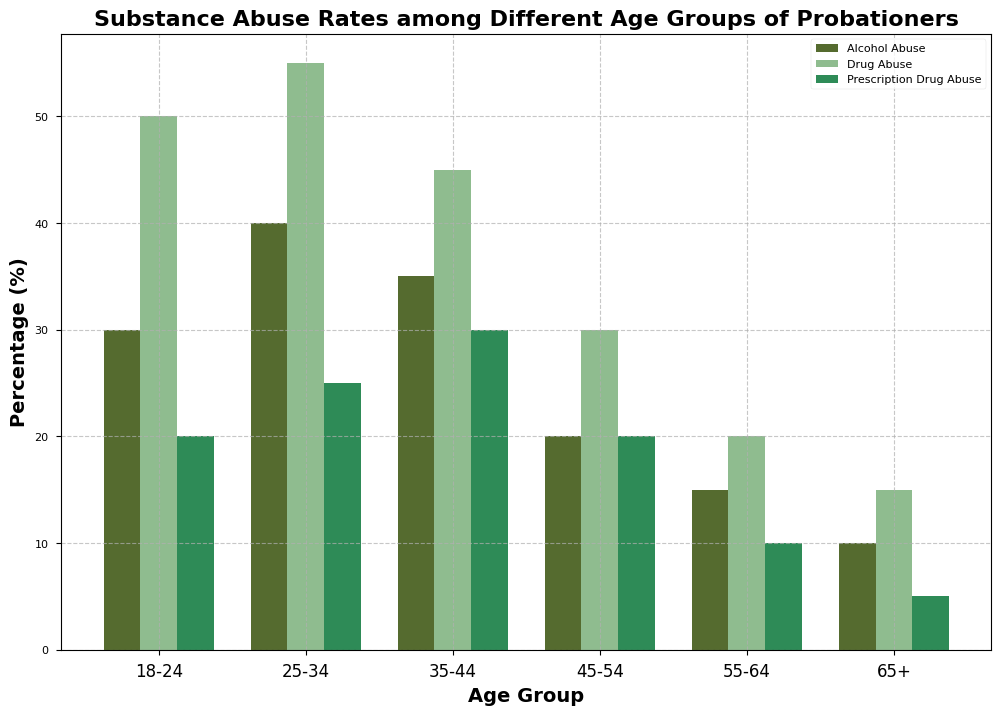Which age group has the highest rate of drug abuse? By visually comparing the heights of the drug abuse bars, the age group 25-34 has the highest bar.
Answer: 25-34 Which age group has the lowest rate of alcohol abuse? By visually examining the heights of the alcohol abuse bars, the 65+ age group has the shortest bar.
Answer: 65+ What is the difference in drug abuse rates between the age groups 25-34 and 45-54? The drug abuse rate for 25-34 age group is 55%, and for 45-54 age group, it is 30%. The difference is 55 - 30 = 25%.
Answer: 25% Which type of substance abuse has the highest average rate across all age groups? Calculate the average rate for alcohol, drug, and prescription drug abuse across all age groups. For alcohol: (30 + 40 + 35 + 20 + 15 + 10)/6 = 25%, for drug: (50 + 55 + 45 + 30 + 20 + 15)/6 = 35.83%, for prescription: (20 + 25 + 30 + 20 + 10 + 5)/6 = 18.33%. Drug abuse has the highest average rate.
Answer: Drug Abuse What is the combined total rate of all types of substance abuse for the age group 18-24? Sum the rates of alcohol (30%), drug (50%), and prescription drug (20%) abuse for 18-24 age group. 30 + 50 + 20 = 100%.
Answer: 100% What is the average rate of drug abuse across the age groups 35-44 and 55-64? Calculate the average for the drug abuse rates for the 35-44 (45%) and 55-64 (20%) age groups: (45 + 20) / 2 = 32.5%.
Answer: 32.5% Which age group has a higher difference in rates between alcohol abuse and prescription drug abuse, 18-24 or 45-54? The difference for 18-24 is 30 - 20 = 10%, and for 45-54 is 20 - 20 = 0%. Therefore, 18-24 has a higher difference.
Answer: 18-24 Between the age groups 25-34 and 35-44, which has a higher rate of prescription drug abuse? By visually comparing the heights of the prescription drug abuse bars, the 35-44 age group has a bar height of 30%, whereas the 25-34 age group has 25%, so 35-44 is higher.
Answer: 35-44 Is the rate of alcohol abuse in the age group 25-34 greater than or equal to the rate of prescription drug abuse in the age group 45-54? The rate of alcohol abuse in 25-34 is 40%, and the rate of prescription drug abuse in 45-54 is 20%. Since 40% is greater than 20%, the statement is true.
Answer: Yes 